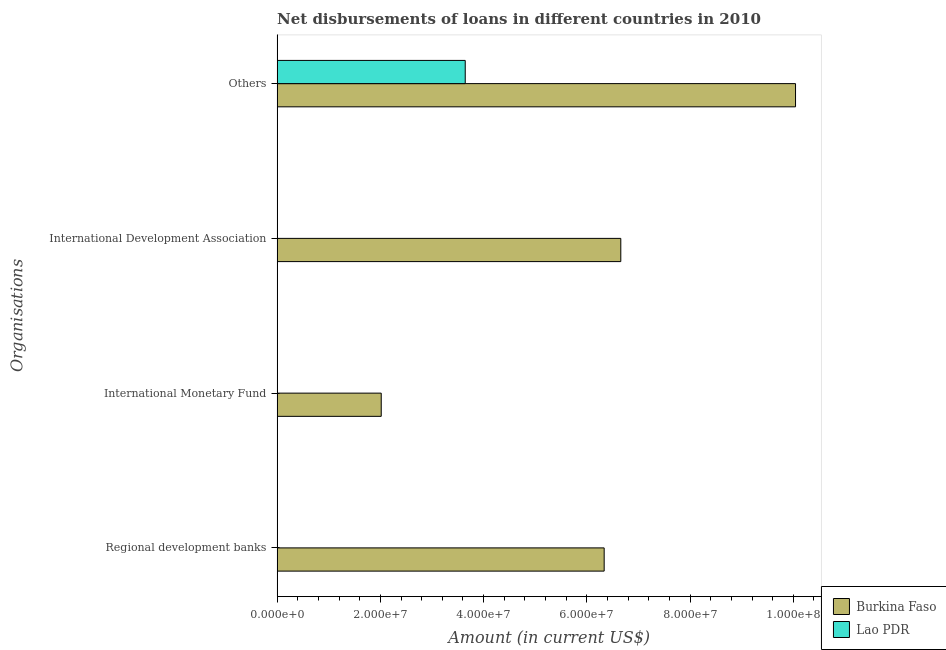How many different coloured bars are there?
Provide a short and direct response. 2. Are the number of bars on each tick of the Y-axis equal?
Keep it short and to the point. No. How many bars are there on the 4th tick from the top?
Provide a succinct answer. 1. What is the label of the 3rd group of bars from the top?
Your answer should be very brief. International Monetary Fund. What is the amount of loan disimbursed by international development association in Burkina Faso?
Your response must be concise. 6.66e+07. Across all countries, what is the maximum amount of loan disimbursed by international development association?
Offer a terse response. 6.66e+07. In which country was the amount of loan disimbursed by international monetary fund maximum?
Ensure brevity in your answer.  Burkina Faso. What is the total amount of loan disimbursed by international development association in the graph?
Keep it short and to the point. 6.66e+07. What is the difference between the amount of loan disimbursed by other organisations in Burkina Faso and that in Lao PDR?
Offer a terse response. 6.40e+07. What is the difference between the amount of loan disimbursed by other organisations in Lao PDR and the amount of loan disimbursed by international development association in Burkina Faso?
Your answer should be very brief. -3.01e+07. What is the average amount of loan disimbursed by international monetary fund per country?
Your answer should be compact. 1.01e+07. What is the difference between the amount of loan disimbursed by other organisations and amount of loan disimbursed by international development association in Burkina Faso?
Offer a very short reply. 3.38e+07. In how many countries, is the amount of loan disimbursed by regional development banks greater than 12000000 US$?
Make the answer very short. 1. What is the ratio of the amount of loan disimbursed by other organisations in Burkina Faso to that in Lao PDR?
Your answer should be very brief. 2.76. What is the difference between the highest and the second highest amount of loan disimbursed by other organisations?
Your answer should be very brief. 6.40e+07. What is the difference between the highest and the lowest amount of loan disimbursed by international monetary fund?
Provide a short and direct response. 2.02e+07. Is it the case that in every country, the sum of the amount of loan disimbursed by regional development banks and amount of loan disimbursed by international monetary fund is greater than the amount of loan disimbursed by international development association?
Keep it short and to the point. No. How many legend labels are there?
Offer a very short reply. 2. What is the title of the graph?
Make the answer very short. Net disbursements of loans in different countries in 2010. What is the label or title of the X-axis?
Provide a short and direct response. Amount (in current US$). What is the label or title of the Y-axis?
Provide a short and direct response. Organisations. What is the Amount (in current US$) of Burkina Faso in Regional development banks?
Keep it short and to the point. 6.34e+07. What is the Amount (in current US$) in Burkina Faso in International Monetary Fund?
Your answer should be compact. 2.02e+07. What is the Amount (in current US$) of Lao PDR in International Monetary Fund?
Ensure brevity in your answer.  0. What is the Amount (in current US$) of Burkina Faso in International Development Association?
Provide a succinct answer. 6.66e+07. What is the Amount (in current US$) of Lao PDR in International Development Association?
Ensure brevity in your answer.  0. What is the Amount (in current US$) of Burkina Faso in Others?
Make the answer very short. 1.00e+08. What is the Amount (in current US$) of Lao PDR in Others?
Ensure brevity in your answer.  3.64e+07. Across all Organisations, what is the maximum Amount (in current US$) in Burkina Faso?
Ensure brevity in your answer.  1.00e+08. Across all Organisations, what is the maximum Amount (in current US$) in Lao PDR?
Provide a short and direct response. 3.64e+07. Across all Organisations, what is the minimum Amount (in current US$) of Burkina Faso?
Keep it short and to the point. 2.02e+07. Across all Organisations, what is the minimum Amount (in current US$) in Lao PDR?
Your response must be concise. 0. What is the total Amount (in current US$) of Burkina Faso in the graph?
Keep it short and to the point. 2.51e+08. What is the total Amount (in current US$) in Lao PDR in the graph?
Make the answer very short. 3.64e+07. What is the difference between the Amount (in current US$) in Burkina Faso in Regional development banks and that in International Monetary Fund?
Make the answer very short. 4.32e+07. What is the difference between the Amount (in current US$) of Burkina Faso in Regional development banks and that in International Development Association?
Ensure brevity in your answer.  -3.22e+06. What is the difference between the Amount (in current US$) in Burkina Faso in Regional development banks and that in Others?
Your response must be concise. -3.71e+07. What is the difference between the Amount (in current US$) in Burkina Faso in International Monetary Fund and that in International Development Association?
Ensure brevity in your answer.  -4.64e+07. What is the difference between the Amount (in current US$) in Burkina Faso in International Monetary Fund and that in Others?
Provide a succinct answer. -8.03e+07. What is the difference between the Amount (in current US$) in Burkina Faso in International Development Association and that in Others?
Your response must be concise. -3.38e+07. What is the difference between the Amount (in current US$) in Burkina Faso in Regional development banks and the Amount (in current US$) in Lao PDR in Others?
Your response must be concise. 2.69e+07. What is the difference between the Amount (in current US$) in Burkina Faso in International Monetary Fund and the Amount (in current US$) in Lao PDR in Others?
Provide a succinct answer. -1.63e+07. What is the difference between the Amount (in current US$) in Burkina Faso in International Development Association and the Amount (in current US$) in Lao PDR in Others?
Make the answer very short. 3.01e+07. What is the average Amount (in current US$) of Burkina Faso per Organisations?
Provide a short and direct response. 6.26e+07. What is the average Amount (in current US$) in Lao PDR per Organisations?
Offer a very short reply. 9.11e+06. What is the difference between the Amount (in current US$) in Burkina Faso and Amount (in current US$) in Lao PDR in Others?
Your answer should be compact. 6.40e+07. What is the ratio of the Amount (in current US$) of Burkina Faso in Regional development banks to that in International Monetary Fund?
Keep it short and to the point. 3.14. What is the ratio of the Amount (in current US$) in Burkina Faso in Regional development banks to that in International Development Association?
Make the answer very short. 0.95. What is the ratio of the Amount (in current US$) in Burkina Faso in Regional development banks to that in Others?
Offer a terse response. 0.63. What is the ratio of the Amount (in current US$) of Burkina Faso in International Monetary Fund to that in International Development Association?
Make the answer very short. 0.3. What is the ratio of the Amount (in current US$) in Burkina Faso in International Monetary Fund to that in Others?
Your answer should be very brief. 0.2. What is the ratio of the Amount (in current US$) in Burkina Faso in International Development Association to that in Others?
Ensure brevity in your answer.  0.66. What is the difference between the highest and the second highest Amount (in current US$) of Burkina Faso?
Ensure brevity in your answer.  3.38e+07. What is the difference between the highest and the lowest Amount (in current US$) of Burkina Faso?
Your answer should be very brief. 8.03e+07. What is the difference between the highest and the lowest Amount (in current US$) of Lao PDR?
Provide a short and direct response. 3.64e+07. 